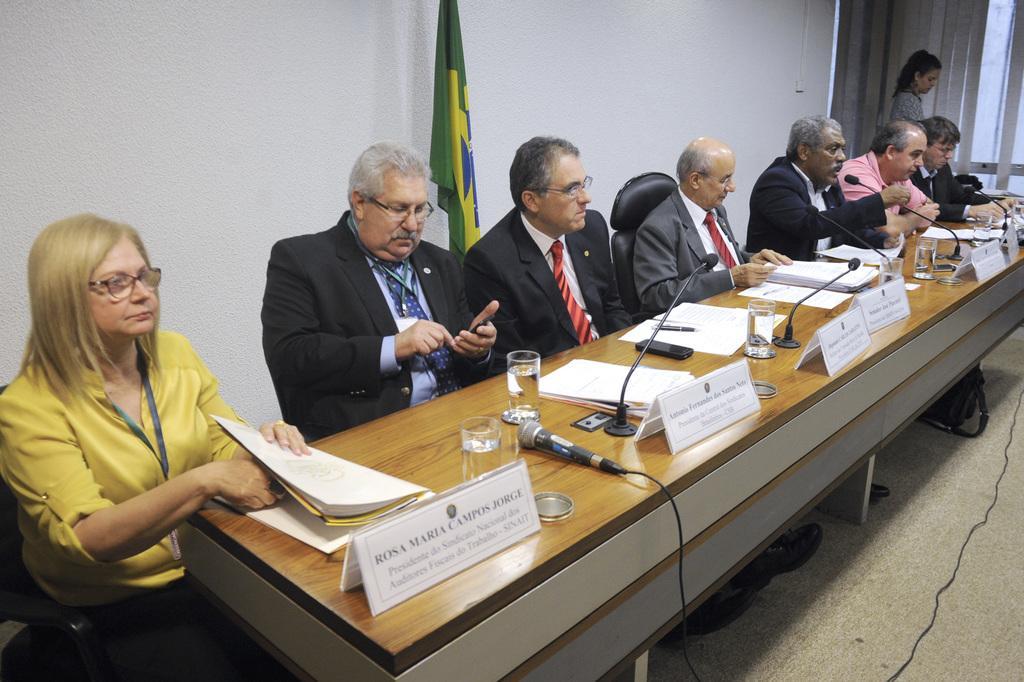Please provide a concise description of this image. In this image we can see a group of people sitting on chairs. One person wearing spectacles is holding mobile in his hand. One woman is holding a file with her hand. In the foreground we can see a group of microphones, glasses, boards with some text, papers, mobile and a pen placed on the table. In the background, we can see a woman standing on the ground. One bag is placed on the floor, a flag, window with curtains. 